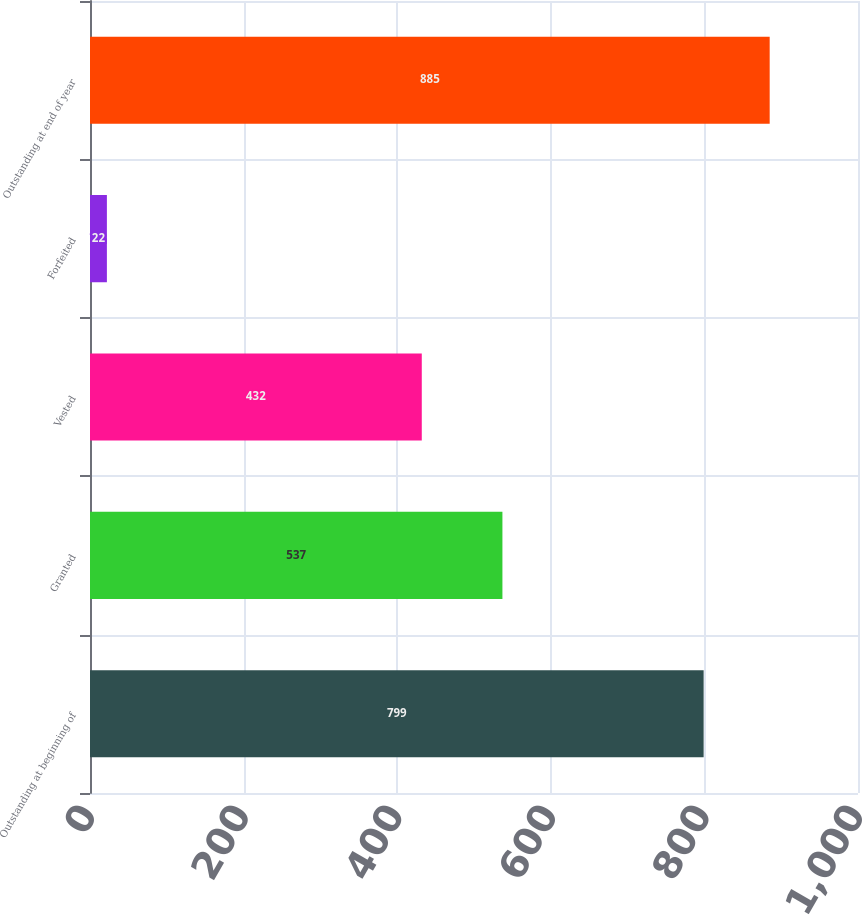<chart> <loc_0><loc_0><loc_500><loc_500><bar_chart><fcel>Outstanding at beginning of<fcel>Granted<fcel>Vested<fcel>Forfeited<fcel>Outstanding at end of year<nl><fcel>799<fcel>537<fcel>432<fcel>22<fcel>885<nl></chart> 